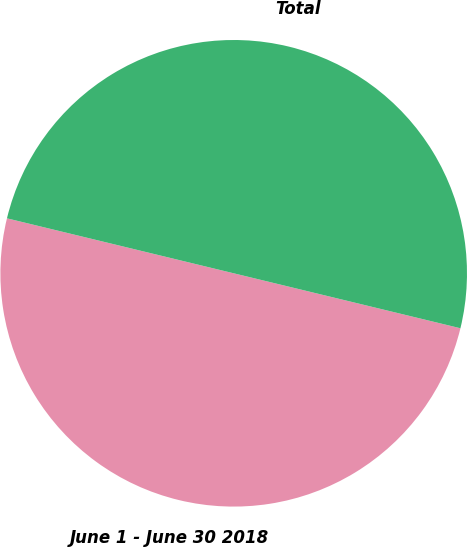<chart> <loc_0><loc_0><loc_500><loc_500><pie_chart><fcel>June 1 - June 30 2018<fcel>Total<nl><fcel>50.0%<fcel>50.0%<nl></chart> 